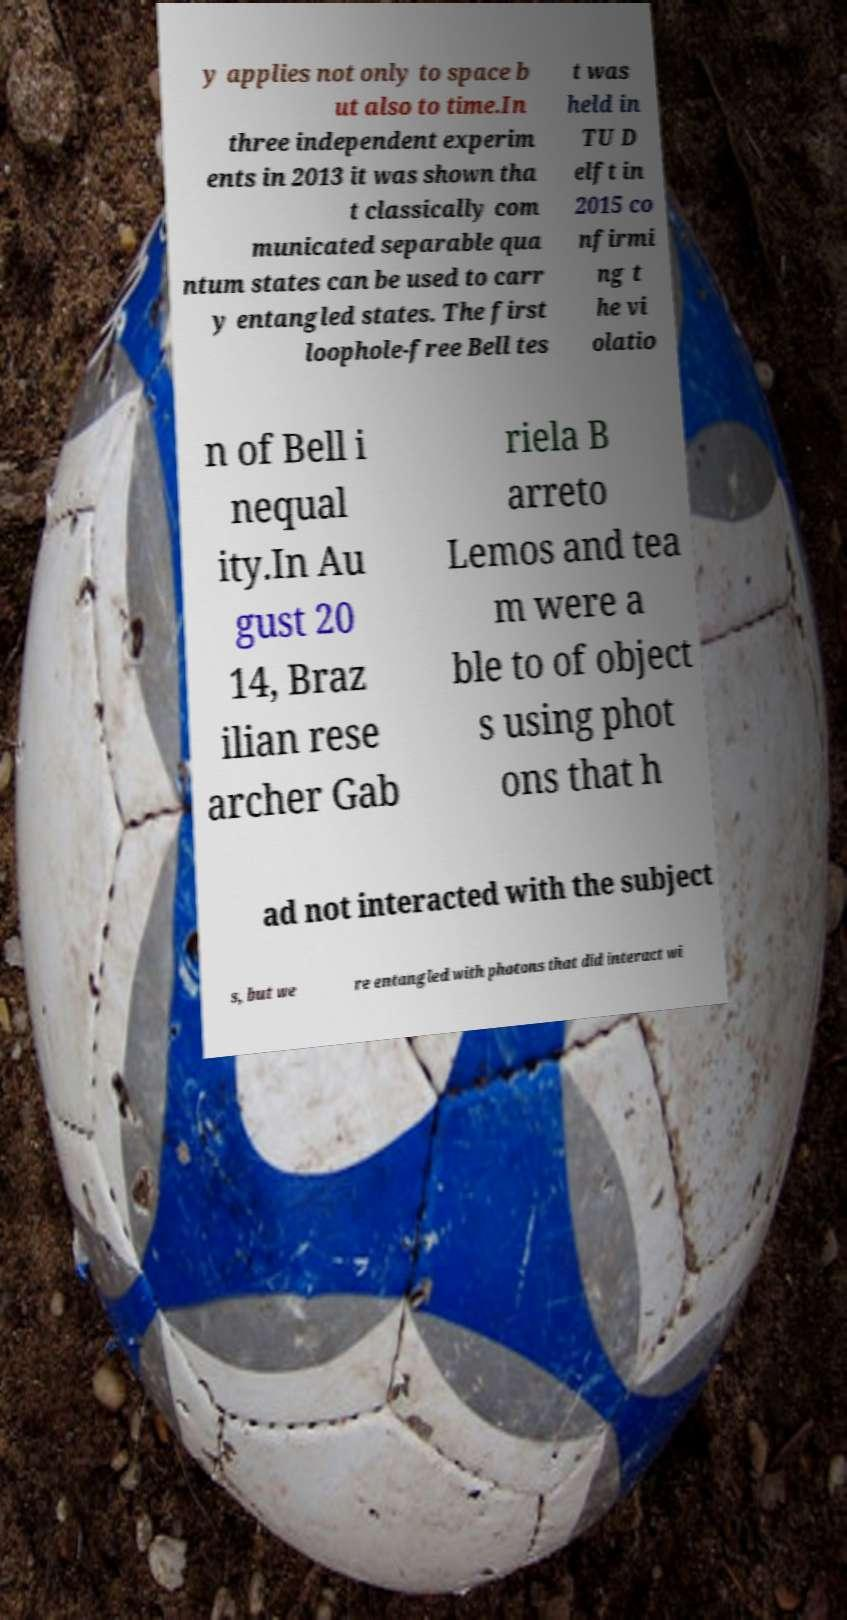Could you extract and type out the text from this image? y applies not only to space b ut also to time.In three independent experim ents in 2013 it was shown tha t classically com municated separable qua ntum states can be used to carr y entangled states. The first loophole-free Bell tes t was held in TU D elft in 2015 co nfirmi ng t he vi olatio n of Bell i nequal ity.In Au gust 20 14, Braz ilian rese archer Gab riela B arreto Lemos and tea m were a ble to of object s using phot ons that h ad not interacted with the subject s, but we re entangled with photons that did interact wi 